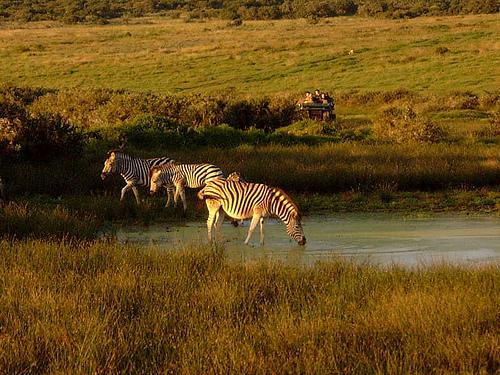Question: what animals are pictured?
Choices:
A. Lions.
B. Tigers.
C. Zebra.
D. Bears.
Answer with the letter. Answer: C Question: how many zebra are there?
Choices:
A. Three.
B. Four.
C. Five.
D. SIx.
Answer with the letter. Answer: A Question: what is in the background?
Choices:
A. The ocean.
B. Grass.
C. Mountains.
D. People.
Answer with the letter. Answer: B Question: what is the lightsource?
Choices:
A. Sunlight.
B. Flashlight.
C. Lamp.
D. Moonlight.
Answer with the letter. Answer: A 